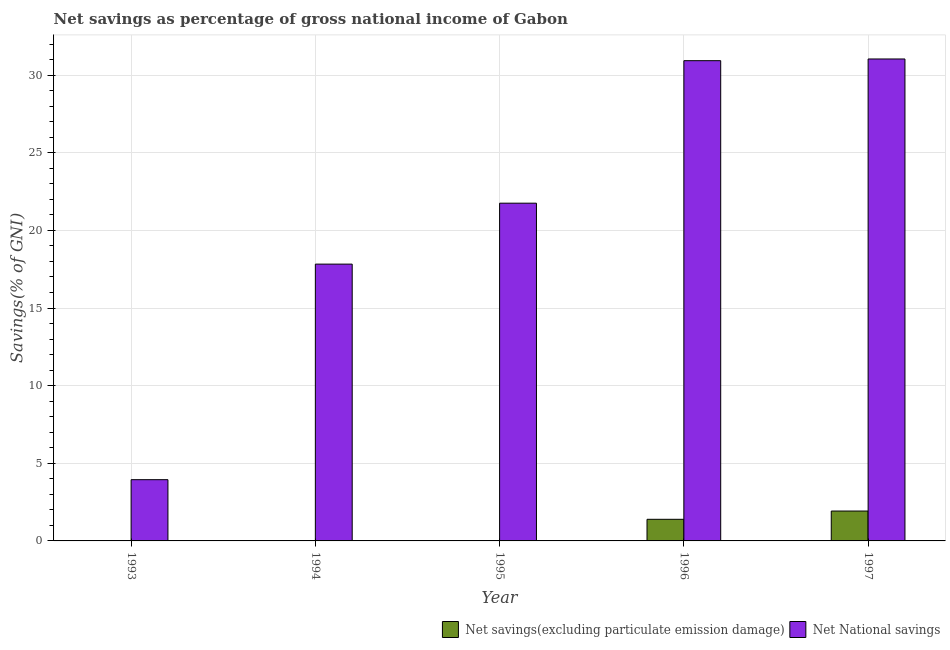How many different coloured bars are there?
Your response must be concise. 2. Are the number of bars per tick equal to the number of legend labels?
Offer a terse response. No. Are the number of bars on each tick of the X-axis equal?
Your answer should be compact. No. How many bars are there on the 4th tick from the left?
Your answer should be compact. 2. Across all years, what is the maximum net savings(excluding particulate emission damage)?
Provide a short and direct response. 1.92. Across all years, what is the minimum net national savings?
Give a very brief answer. 3.94. In which year was the net savings(excluding particulate emission damage) maximum?
Offer a very short reply. 1997. What is the total net savings(excluding particulate emission damage) in the graph?
Offer a very short reply. 3.32. What is the difference between the net national savings in 1993 and that in 1995?
Give a very brief answer. -17.81. What is the difference between the net savings(excluding particulate emission damage) in 1994 and the net national savings in 1995?
Give a very brief answer. 0. What is the average net national savings per year?
Make the answer very short. 21.1. What is the ratio of the net national savings in 1996 to that in 1997?
Provide a short and direct response. 1. What is the difference between the highest and the second highest net national savings?
Give a very brief answer. 0.11. What is the difference between the highest and the lowest net savings(excluding particulate emission damage)?
Offer a very short reply. 1.92. In how many years, is the net national savings greater than the average net national savings taken over all years?
Provide a short and direct response. 3. How many bars are there?
Provide a short and direct response. 7. How many years are there in the graph?
Keep it short and to the point. 5. Are the values on the major ticks of Y-axis written in scientific E-notation?
Offer a terse response. No. Does the graph contain any zero values?
Offer a very short reply. Yes. Does the graph contain grids?
Give a very brief answer. Yes. Where does the legend appear in the graph?
Keep it short and to the point. Bottom right. How are the legend labels stacked?
Your answer should be compact. Horizontal. What is the title of the graph?
Your answer should be very brief. Net savings as percentage of gross national income of Gabon. What is the label or title of the X-axis?
Offer a very short reply. Year. What is the label or title of the Y-axis?
Make the answer very short. Savings(% of GNI). What is the Savings(% of GNI) of Net National savings in 1993?
Your answer should be compact. 3.94. What is the Savings(% of GNI) in Net National savings in 1994?
Provide a short and direct response. 17.83. What is the Savings(% of GNI) in Net National savings in 1995?
Your response must be concise. 21.75. What is the Savings(% of GNI) in Net savings(excluding particulate emission damage) in 1996?
Ensure brevity in your answer.  1.39. What is the Savings(% of GNI) of Net National savings in 1996?
Your answer should be very brief. 30.93. What is the Savings(% of GNI) of Net savings(excluding particulate emission damage) in 1997?
Your answer should be very brief. 1.92. What is the Savings(% of GNI) of Net National savings in 1997?
Your answer should be very brief. 31.04. Across all years, what is the maximum Savings(% of GNI) of Net savings(excluding particulate emission damage)?
Offer a very short reply. 1.92. Across all years, what is the maximum Savings(% of GNI) of Net National savings?
Your answer should be very brief. 31.04. Across all years, what is the minimum Savings(% of GNI) in Net National savings?
Keep it short and to the point. 3.94. What is the total Savings(% of GNI) in Net savings(excluding particulate emission damage) in the graph?
Make the answer very short. 3.32. What is the total Savings(% of GNI) of Net National savings in the graph?
Give a very brief answer. 105.5. What is the difference between the Savings(% of GNI) in Net National savings in 1993 and that in 1994?
Offer a terse response. -13.88. What is the difference between the Savings(% of GNI) in Net National savings in 1993 and that in 1995?
Provide a succinct answer. -17.81. What is the difference between the Savings(% of GNI) in Net National savings in 1993 and that in 1996?
Provide a succinct answer. -26.99. What is the difference between the Savings(% of GNI) of Net National savings in 1993 and that in 1997?
Your answer should be compact. -27.1. What is the difference between the Savings(% of GNI) of Net National savings in 1994 and that in 1995?
Provide a succinct answer. -3.92. What is the difference between the Savings(% of GNI) of Net National savings in 1994 and that in 1996?
Provide a short and direct response. -13.1. What is the difference between the Savings(% of GNI) in Net National savings in 1994 and that in 1997?
Give a very brief answer. -13.21. What is the difference between the Savings(% of GNI) of Net National savings in 1995 and that in 1996?
Provide a short and direct response. -9.18. What is the difference between the Savings(% of GNI) in Net National savings in 1995 and that in 1997?
Provide a short and direct response. -9.29. What is the difference between the Savings(% of GNI) in Net savings(excluding particulate emission damage) in 1996 and that in 1997?
Your response must be concise. -0.53. What is the difference between the Savings(% of GNI) in Net National savings in 1996 and that in 1997?
Your answer should be compact. -0.11. What is the difference between the Savings(% of GNI) of Net savings(excluding particulate emission damage) in 1996 and the Savings(% of GNI) of Net National savings in 1997?
Give a very brief answer. -29.65. What is the average Savings(% of GNI) of Net savings(excluding particulate emission damage) per year?
Ensure brevity in your answer.  0.66. What is the average Savings(% of GNI) of Net National savings per year?
Offer a very short reply. 21.1. In the year 1996, what is the difference between the Savings(% of GNI) of Net savings(excluding particulate emission damage) and Savings(% of GNI) of Net National savings?
Provide a short and direct response. -29.54. In the year 1997, what is the difference between the Savings(% of GNI) of Net savings(excluding particulate emission damage) and Savings(% of GNI) of Net National savings?
Your response must be concise. -29.12. What is the ratio of the Savings(% of GNI) in Net National savings in 1993 to that in 1994?
Your response must be concise. 0.22. What is the ratio of the Savings(% of GNI) in Net National savings in 1993 to that in 1995?
Your response must be concise. 0.18. What is the ratio of the Savings(% of GNI) of Net National savings in 1993 to that in 1996?
Keep it short and to the point. 0.13. What is the ratio of the Savings(% of GNI) of Net National savings in 1993 to that in 1997?
Give a very brief answer. 0.13. What is the ratio of the Savings(% of GNI) of Net National savings in 1994 to that in 1995?
Keep it short and to the point. 0.82. What is the ratio of the Savings(% of GNI) of Net National savings in 1994 to that in 1996?
Keep it short and to the point. 0.58. What is the ratio of the Savings(% of GNI) in Net National savings in 1994 to that in 1997?
Your answer should be very brief. 0.57. What is the ratio of the Savings(% of GNI) in Net National savings in 1995 to that in 1996?
Make the answer very short. 0.7. What is the ratio of the Savings(% of GNI) in Net National savings in 1995 to that in 1997?
Offer a terse response. 0.7. What is the ratio of the Savings(% of GNI) of Net savings(excluding particulate emission damage) in 1996 to that in 1997?
Make the answer very short. 0.72. What is the difference between the highest and the second highest Savings(% of GNI) of Net National savings?
Ensure brevity in your answer.  0.11. What is the difference between the highest and the lowest Savings(% of GNI) in Net savings(excluding particulate emission damage)?
Your response must be concise. 1.92. What is the difference between the highest and the lowest Savings(% of GNI) in Net National savings?
Offer a terse response. 27.1. 